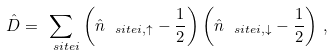Convert formula to latex. <formula><loc_0><loc_0><loc_500><loc_500>\hat { D } = \sum _ { \ s i t e i } \left ( \hat { n } _ { \ s i t e i , \uparrow } - \frac { 1 } { 2 } \right ) \left ( \hat { n } _ { \ s i t e i , \downarrow } - \frac { 1 } { 2 } \right ) \, ,</formula> 